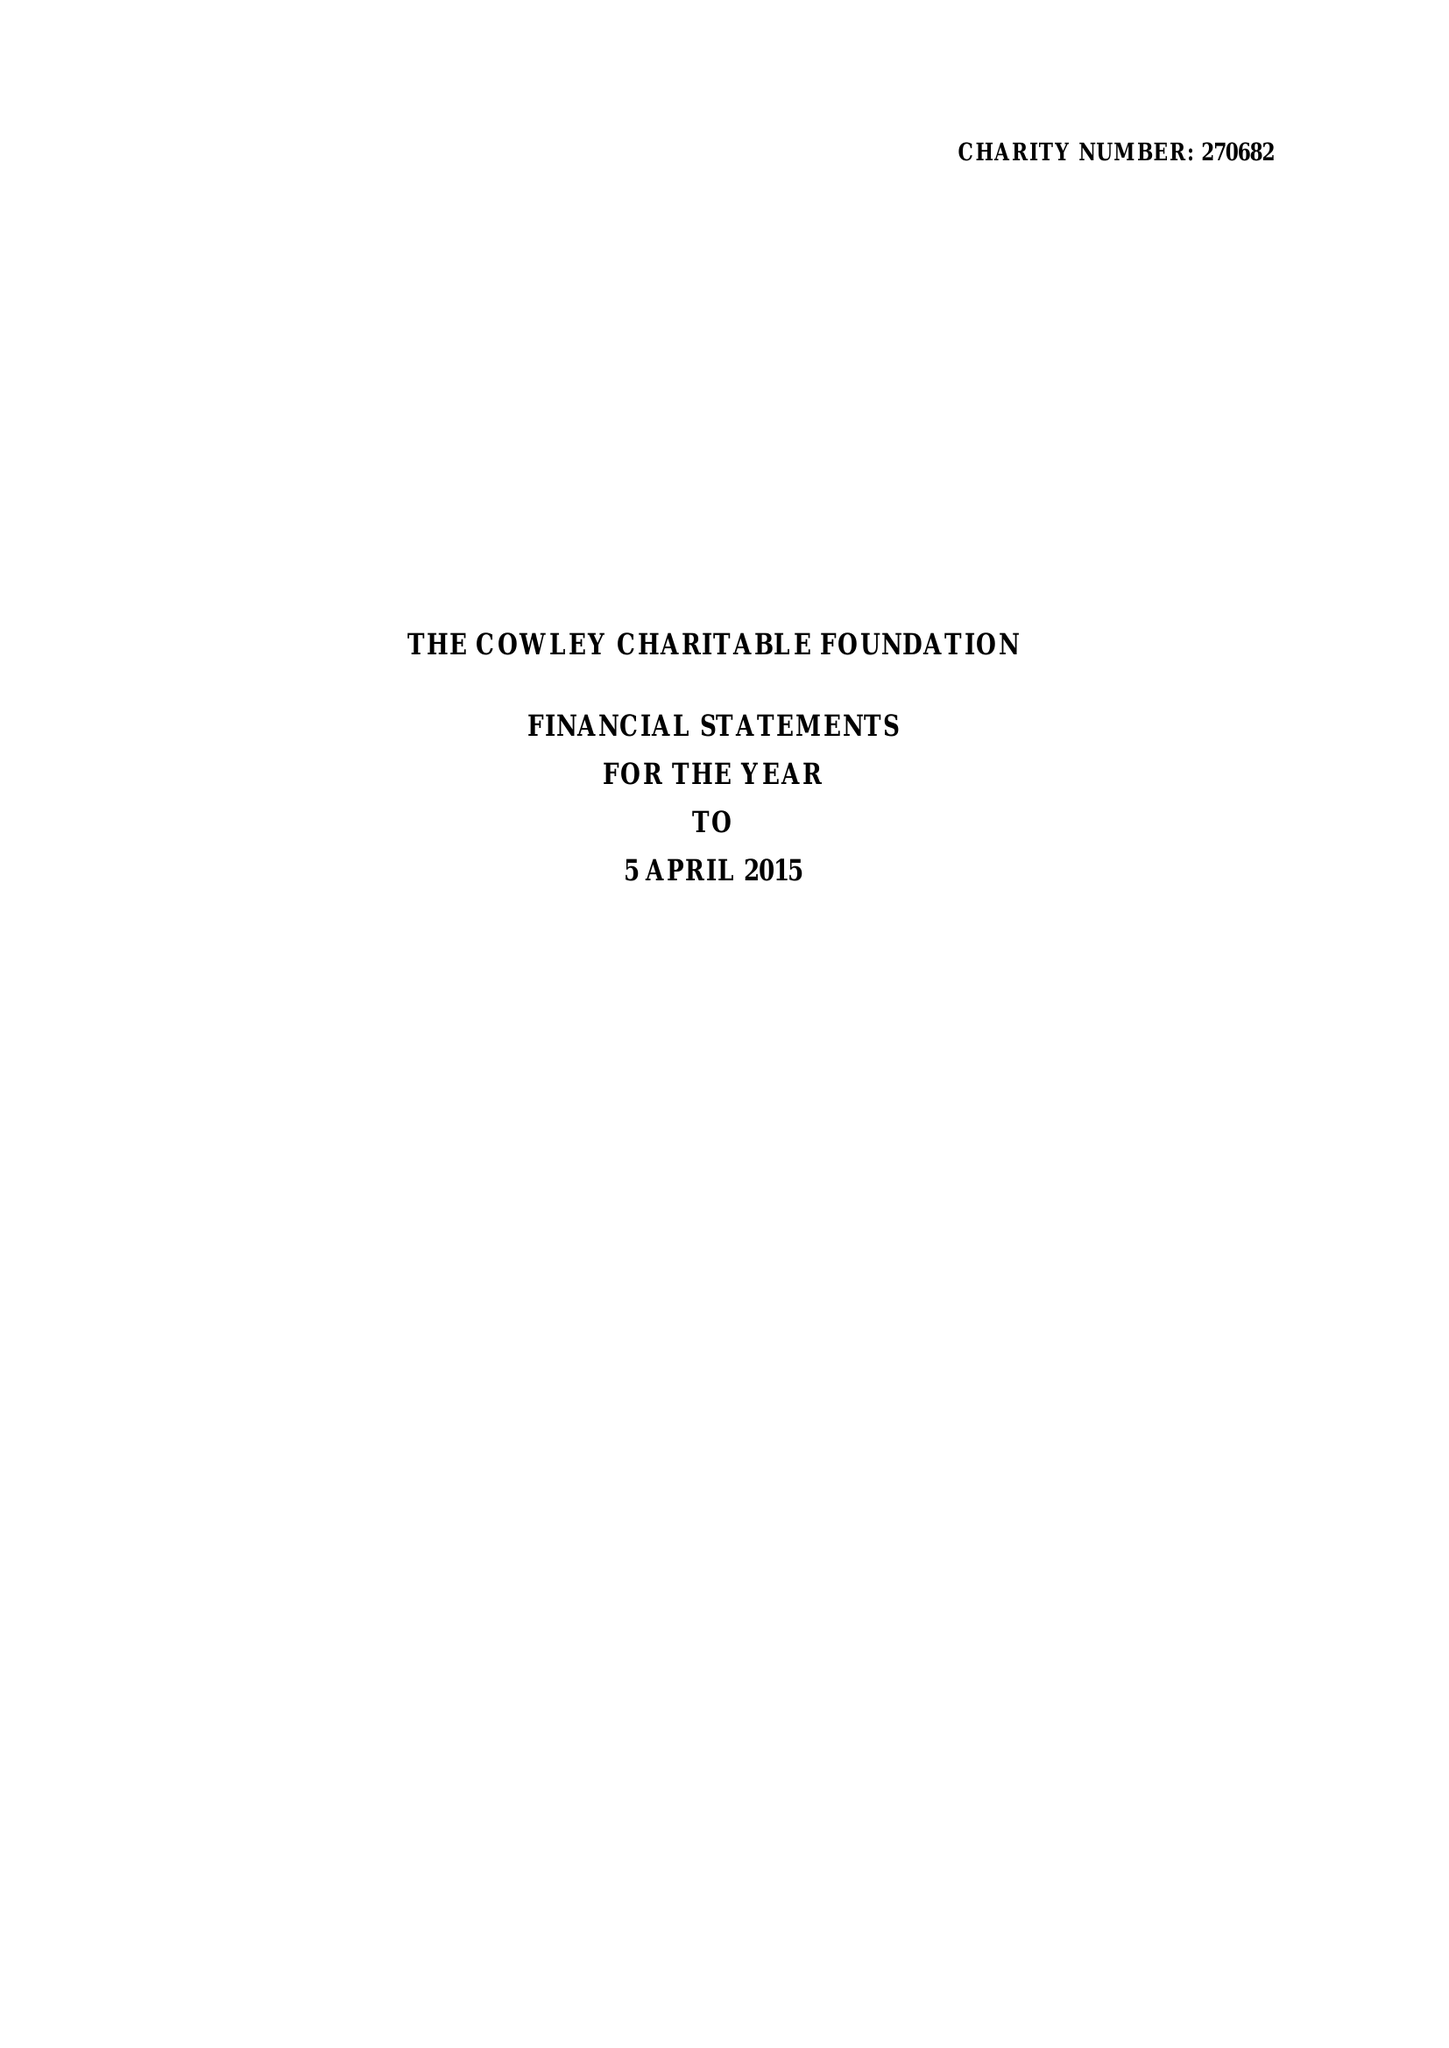What is the value for the address__post_town?
Answer the question using a single word or phrase. LONDON 